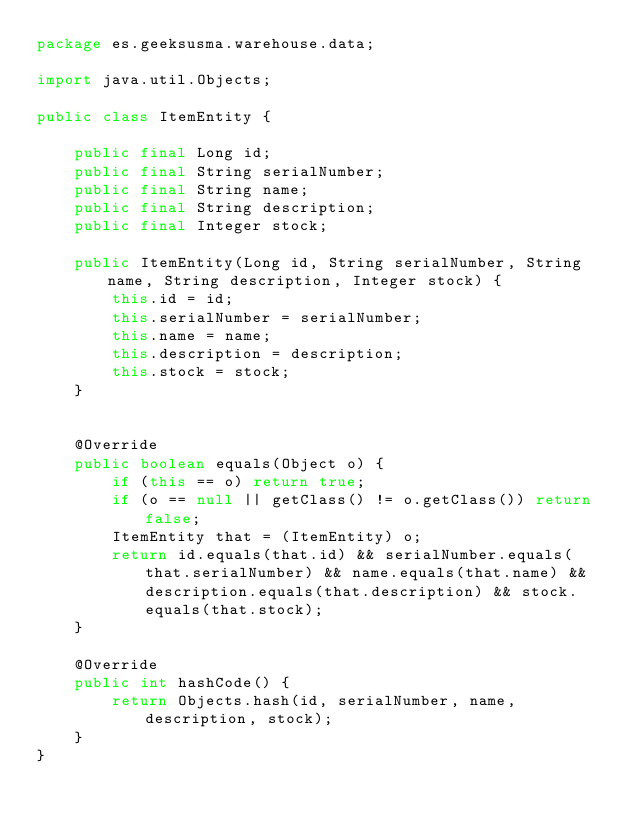<code> <loc_0><loc_0><loc_500><loc_500><_Java_>package es.geeksusma.warehouse.data;

import java.util.Objects;

public class ItemEntity {

    public final Long id;
    public final String serialNumber;
    public final String name;
    public final String description;
    public final Integer stock;

    public ItemEntity(Long id, String serialNumber, String name, String description, Integer stock) {
        this.id = id;
        this.serialNumber = serialNumber;
        this.name = name;
        this.description = description;
        this.stock = stock;
    }


    @Override
    public boolean equals(Object o) {
        if (this == o) return true;
        if (o == null || getClass() != o.getClass()) return false;
        ItemEntity that = (ItemEntity) o;
        return id.equals(that.id) && serialNumber.equals(that.serialNumber) && name.equals(that.name) && description.equals(that.description) && stock.equals(that.stock);
    }

    @Override
    public int hashCode() {
        return Objects.hash(id, serialNumber, name, description, stock);
    }
}

</code> 